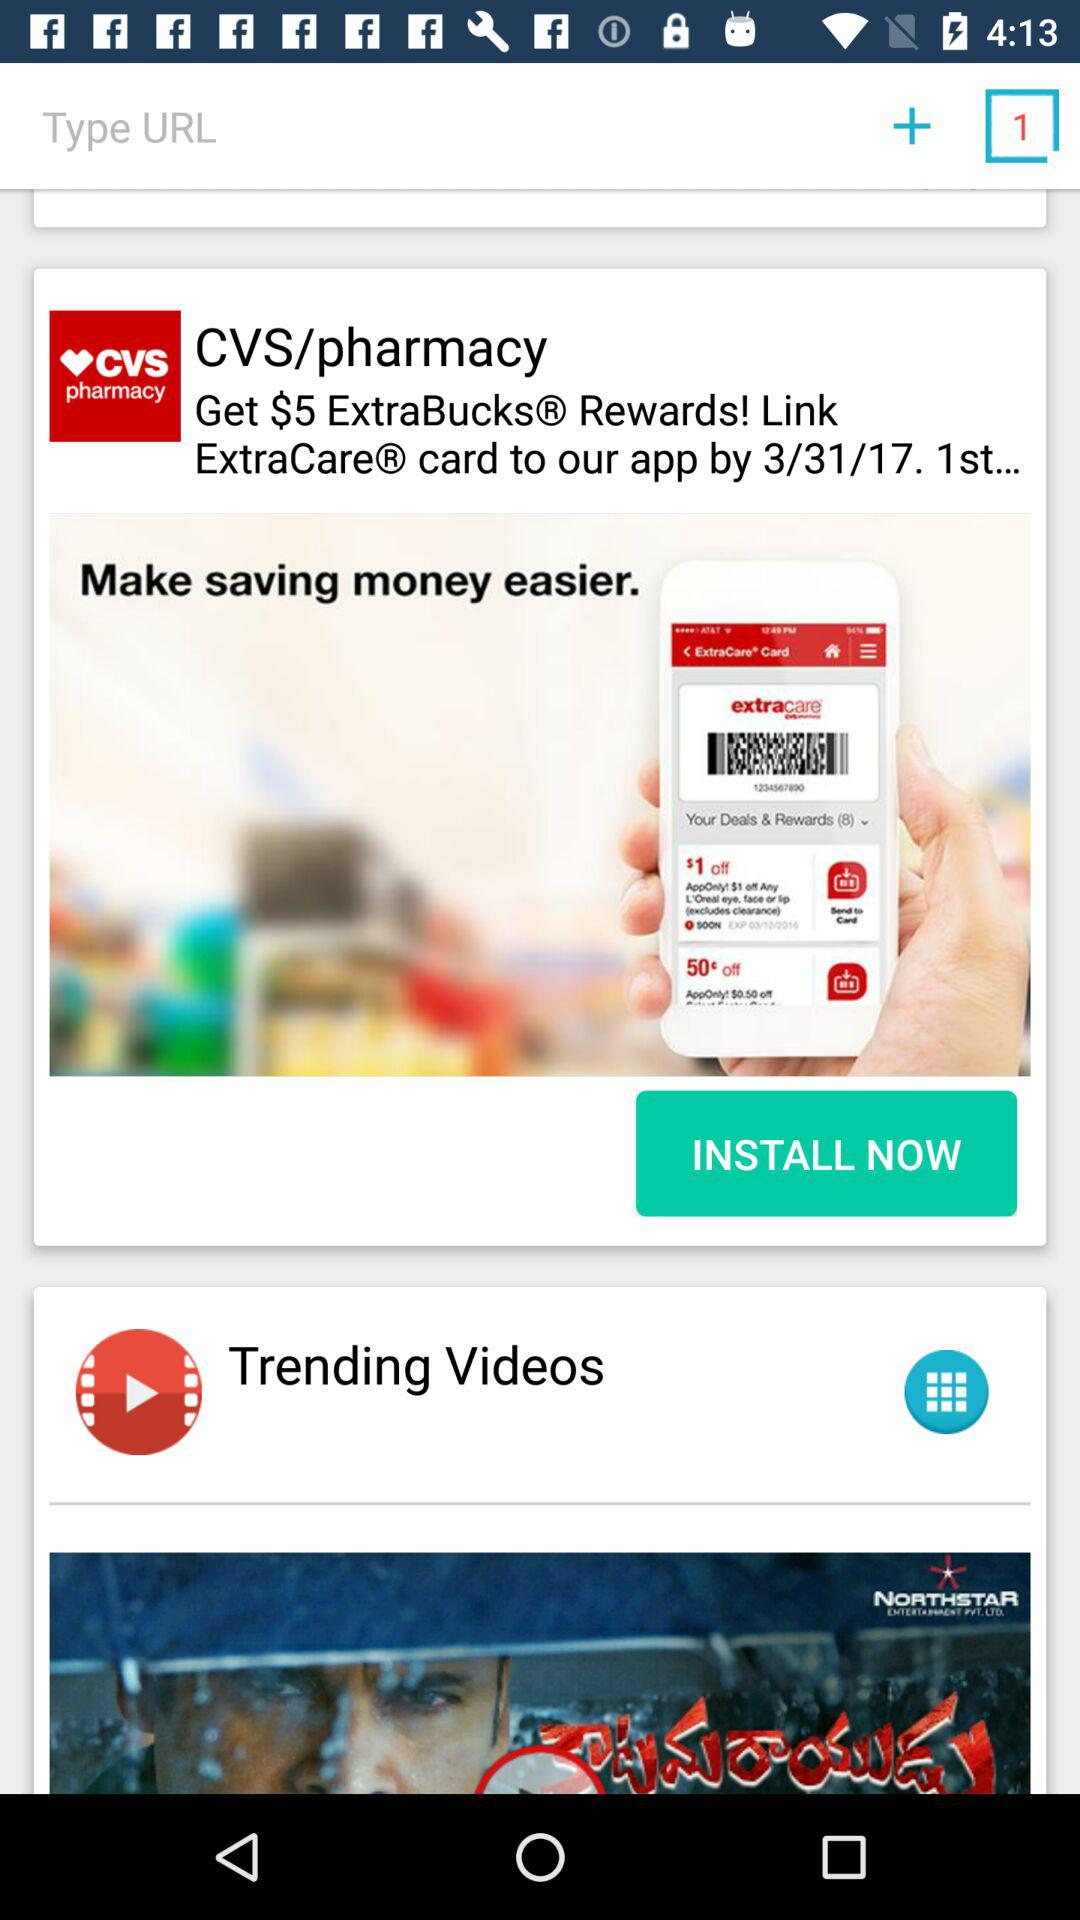What is the total number of tabs open? The tab open is 1. 